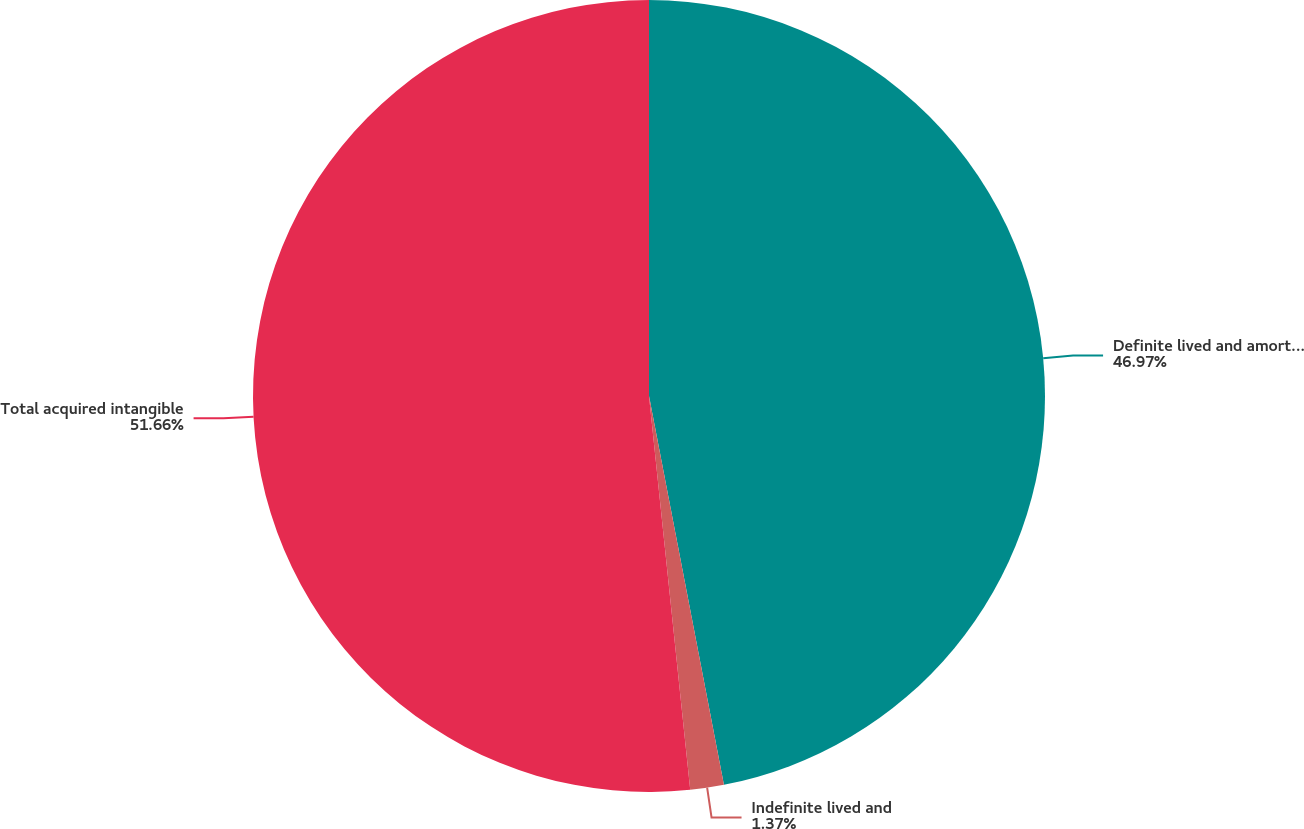Convert chart to OTSL. <chart><loc_0><loc_0><loc_500><loc_500><pie_chart><fcel>Definite lived and amortizable<fcel>Indefinite lived and<fcel>Total acquired intangible<nl><fcel>46.97%<fcel>1.37%<fcel>51.66%<nl></chart> 